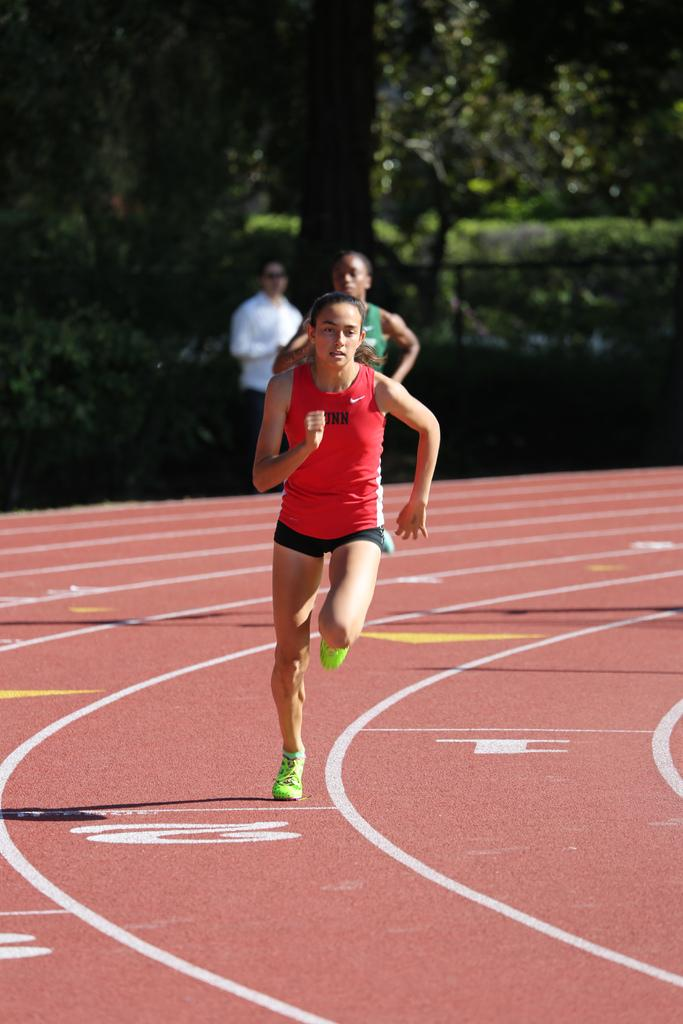What is the main subject of the image? The main subject of the image is girls. What are the girls doing in the image? The girls are running in the image. What can be seen in the background of the image? There are trees in the background of the image. What type of wren can be seen perched on the girls' shoulders in the image? There is no wren present in the image; the girls are running without any birds on their shoulders. 